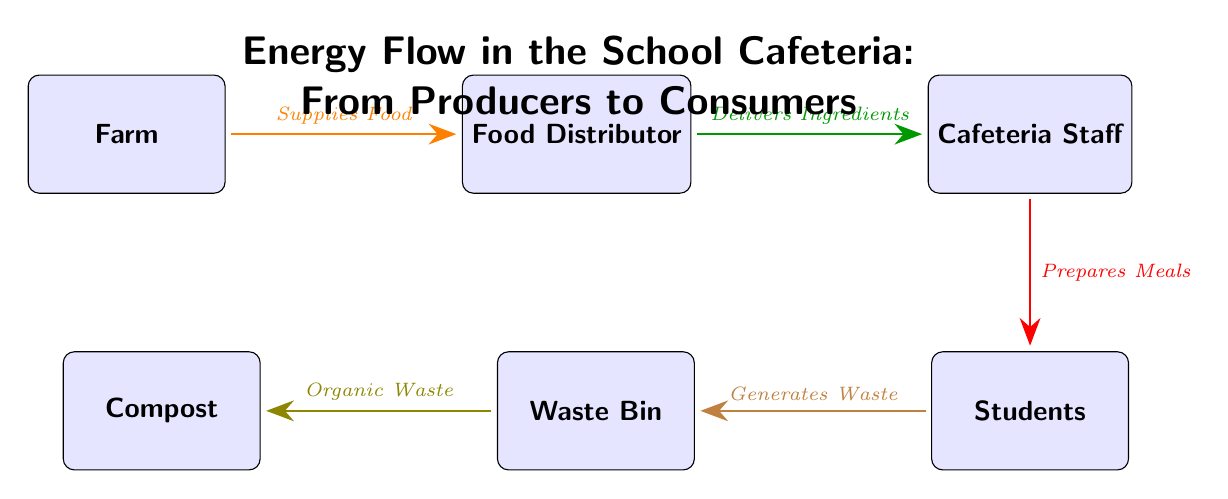What is the first node in the energy flow? The first node is labeled "Farm," which represents the source of food in the cafeteria's energy flow process.
Answer: Farm How many total nodes are in the diagram? By counting the boxes representing different entities, there are a total of five nodes: Farm, Food Distributor, Cafeteria Staff, Students, and Waste Bin.
Answer: 5 What does the arrow labeled "Delivers Ingredients" indicate? This arrow connects the "Food Distributor" and "Cafeteria Staff," indicating that the food distributor delivers ingredients to the cafeteria staff for meal preparation.
Answer: Delivers Ingredients What is the last node in the energy flow? The final node in the flow is the "Compost," representing the destination of organic waste generated when students dispose of their leftovers.
Answer: Compost What do students do with the food provided by the cafeteria staff? Students receive the prepared meals from the cafeteria staff, as indicated by the arrow showing the flow from "Cafeteria Staff" to "Students."
Answer: Prepares Meals Which node receives waste from students? The Waste Bin receives waste, as indicated by the arrow flowing from "Students" to "Waste Bin," showing that students generate waste post-meal consumption.
Answer: Waste Bin What kind of waste does the Compost node receive? The Compost node receives organic waste, which is specifically indicated by the arrow flowing from the "Waste Bin" to the "Compost."
Answer: Organic Waste How does energy flow from producers to consumers in this diagram? Energy flows from the "Farm," where food is produced, to "Food Distributor," then to "Cafeteria Staff," who prepares meals for "Students," effectively representing the entire flow from producers to consumers.
Answer: From Farm to Compost What is the role of the Cafeteria Staff in this flow? The Cafeteria Staff's role is to prepare meals using the ingredients delivered by the distributor, as indicated by the direct connection from the "Cafeteria Staff" to "Students."
Answer: Prepares Meals What happens to the generated waste in the school cafeteria? The generated waste from students goes to the waste bin, and subsequently, organic waste from the waste bin is directed to composting, as demonstrated by the arrows flowing from "Students" to "Waste Bin" and then to "Compost."
Answer: Compost 